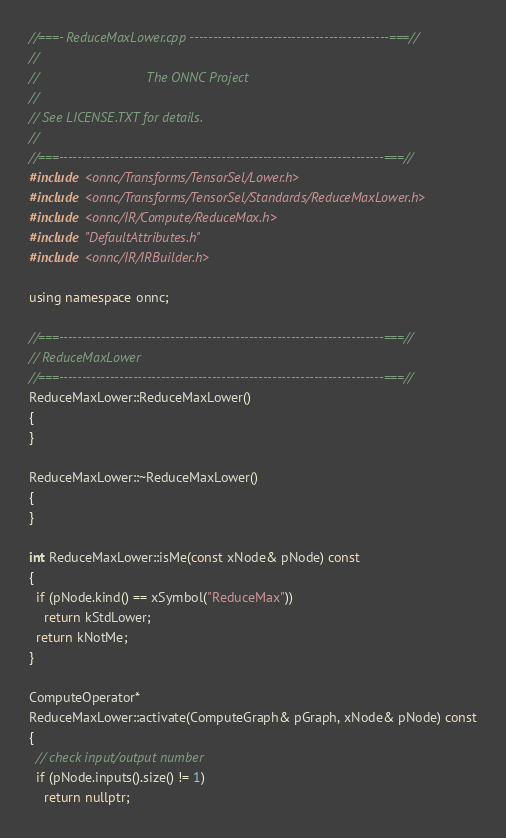Convert code to text. <code><loc_0><loc_0><loc_500><loc_500><_C++_>//===- ReduceMaxLower.cpp -------------------------------------------===//
//
//                             The ONNC Project
//
// See LICENSE.TXT for details.
//
//===----------------------------------------------------------------------===//
#include <onnc/Transforms/TensorSel/Lower.h>
#include <onnc/Transforms/TensorSel/Standards/ReduceMaxLower.h>
#include <onnc/IR/Compute/ReduceMax.h>
#include "DefaultAttributes.h"
#include <onnc/IR/IRBuilder.h>

using namespace onnc;

//===----------------------------------------------------------------------===//
// ReduceMaxLower
//===----------------------------------------------------------------------===//
ReduceMaxLower::ReduceMaxLower()
{
}

ReduceMaxLower::~ReduceMaxLower()
{
}

int ReduceMaxLower::isMe(const xNode& pNode) const
{
  if (pNode.kind() == xSymbol("ReduceMax"))
    return kStdLower;
  return kNotMe;
}

ComputeOperator*
ReduceMaxLower::activate(ComputeGraph& pGraph, xNode& pNode) const
{
  // check input/output number
  if (pNode.inputs().size() != 1)
    return nullptr;
</code> 